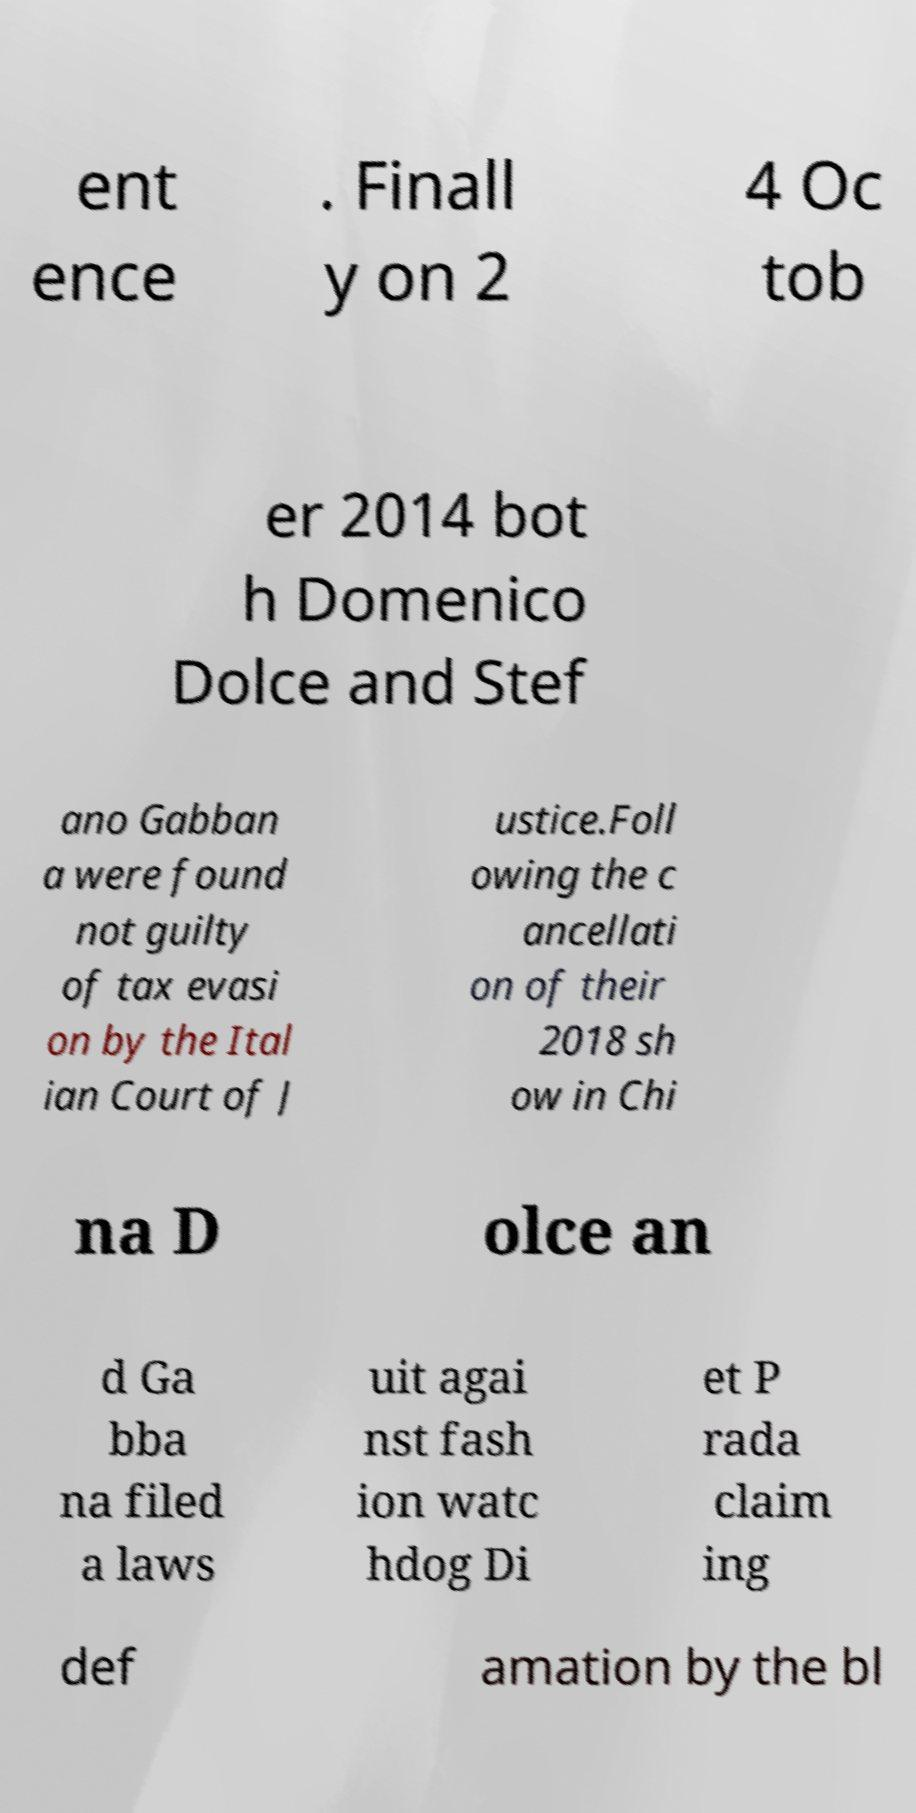There's text embedded in this image that I need extracted. Can you transcribe it verbatim? ent ence . Finall y on 2 4 Oc tob er 2014 bot h Domenico Dolce and Stef ano Gabban a were found not guilty of tax evasi on by the Ital ian Court of J ustice.Foll owing the c ancellati on of their 2018 sh ow in Chi na D olce an d Ga bba na filed a laws uit agai nst fash ion watc hdog Di et P rada claim ing def amation by the bl 